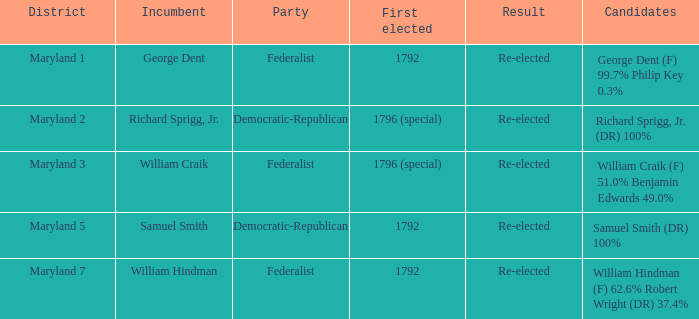What is the district for the party federalist and the candidates are william craik (f) 51.0% benjamin edwards 49.0%? Maryland 3. 